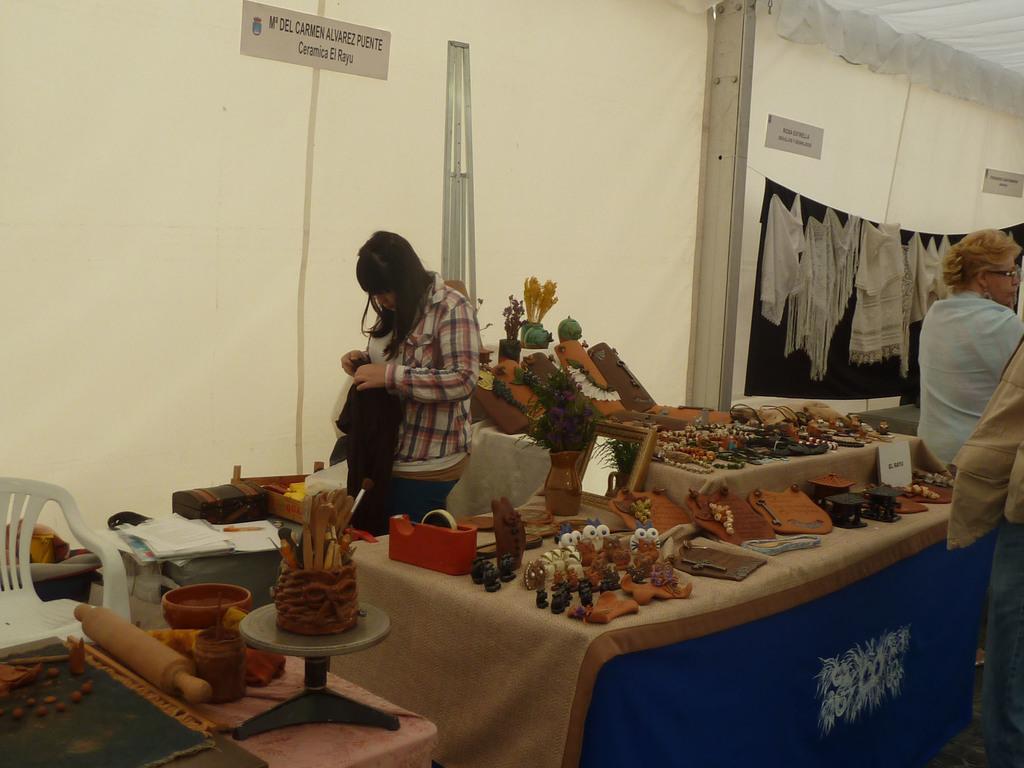How would you summarize this image in a sentence or two? In this picture we can see the stalls. We can see few paper notes, a stand and few clothes. On the tables we can see few objects, a paper note, tape holder. We can see a woman is standing near to a table and holding cloth. We can see papers, pen, a white chair and few objects. On the right side of the picture we can see a woman wearing spectacles. 